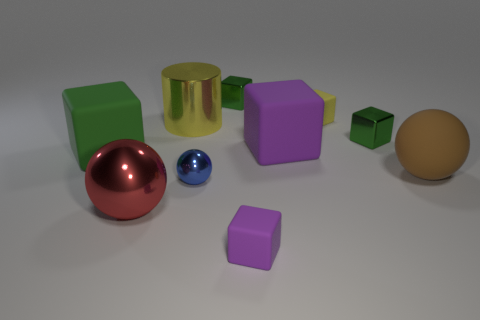Can you tell if the light source is within the image or outside of it? The light source is not visible in the image, but we can infer its general location from the shadows and highlights on the objects. The shadows cast to the right indicate that the light source is to the left side of the objects, and slightly above their plane, outside of the current field of view. 